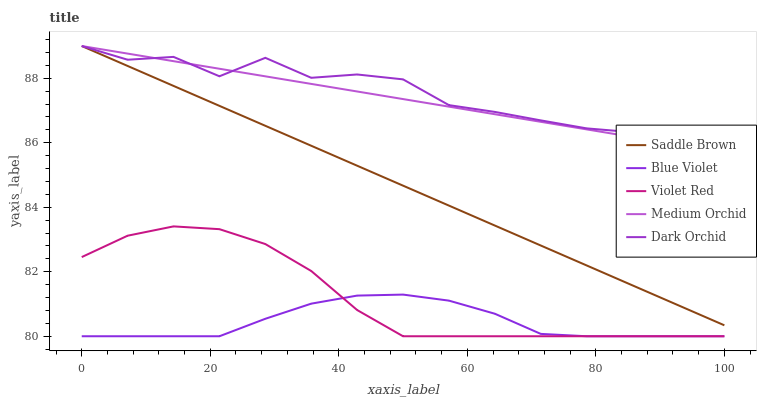Does Blue Violet have the minimum area under the curve?
Answer yes or no. Yes. Does Dark Orchid have the maximum area under the curve?
Answer yes or no. Yes. Does Violet Red have the minimum area under the curve?
Answer yes or no. No. Does Violet Red have the maximum area under the curve?
Answer yes or no. No. Is Medium Orchid the smoothest?
Answer yes or no. Yes. Is Dark Orchid the roughest?
Answer yes or no. Yes. Is Violet Red the smoothest?
Answer yes or no. No. Is Violet Red the roughest?
Answer yes or no. No. Does Medium Orchid have the lowest value?
Answer yes or no. No. Does Saddle Brown have the highest value?
Answer yes or no. Yes. Does Violet Red have the highest value?
Answer yes or no. No. Is Violet Red less than Dark Orchid?
Answer yes or no. Yes. Is Saddle Brown greater than Blue Violet?
Answer yes or no. Yes. Does Saddle Brown intersect Dark Orchid?
Answer yes or no. Yes. Is Saddle Brown less than Dark Orchid?
Answer yes or no. No. Is Saddle Brown greater than Dark Orchid?
Answer yes or no. No. Does Violet Red intersect Dark Orchid?
Answer yes or no. No. 